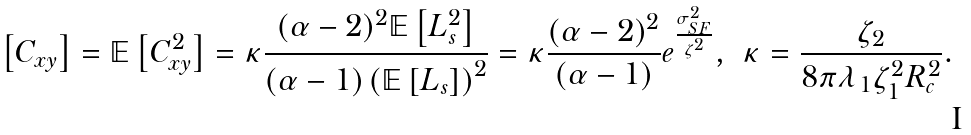<formula> <loc_0><loc_0><loc_500><loc_500>\left [ C _ { x y } \right ] & = \mathbb { E } \left [ C _ { x y } ^ { 2 } \right ] = \kappa \frac { ( \alpha - 2 ) ^ { 2 } \mathbb { E } \left [ L _ { s } ^ { 2 } \right ] } { ( \alpha - 1 ) \left ( \mathbb { E } \left [ L _ { s } \right ] \right ) ^ { 2 } } = \kappa \frac { ( \alpha - 2 ) ^ { 2 } } { ( \alpha - 1 ) } e ^ { \frac { \sigma _ { S F } ^ { 2 } } { \zeta ^ { 2 } } } , & \kappa & = \frac { \zeta _ { 2 } } { 8 \pi \lambda _ { 1 } \zeta _ { 1 } ^ { 2 } R _ { c } ^ { 2 } } .</formula> 